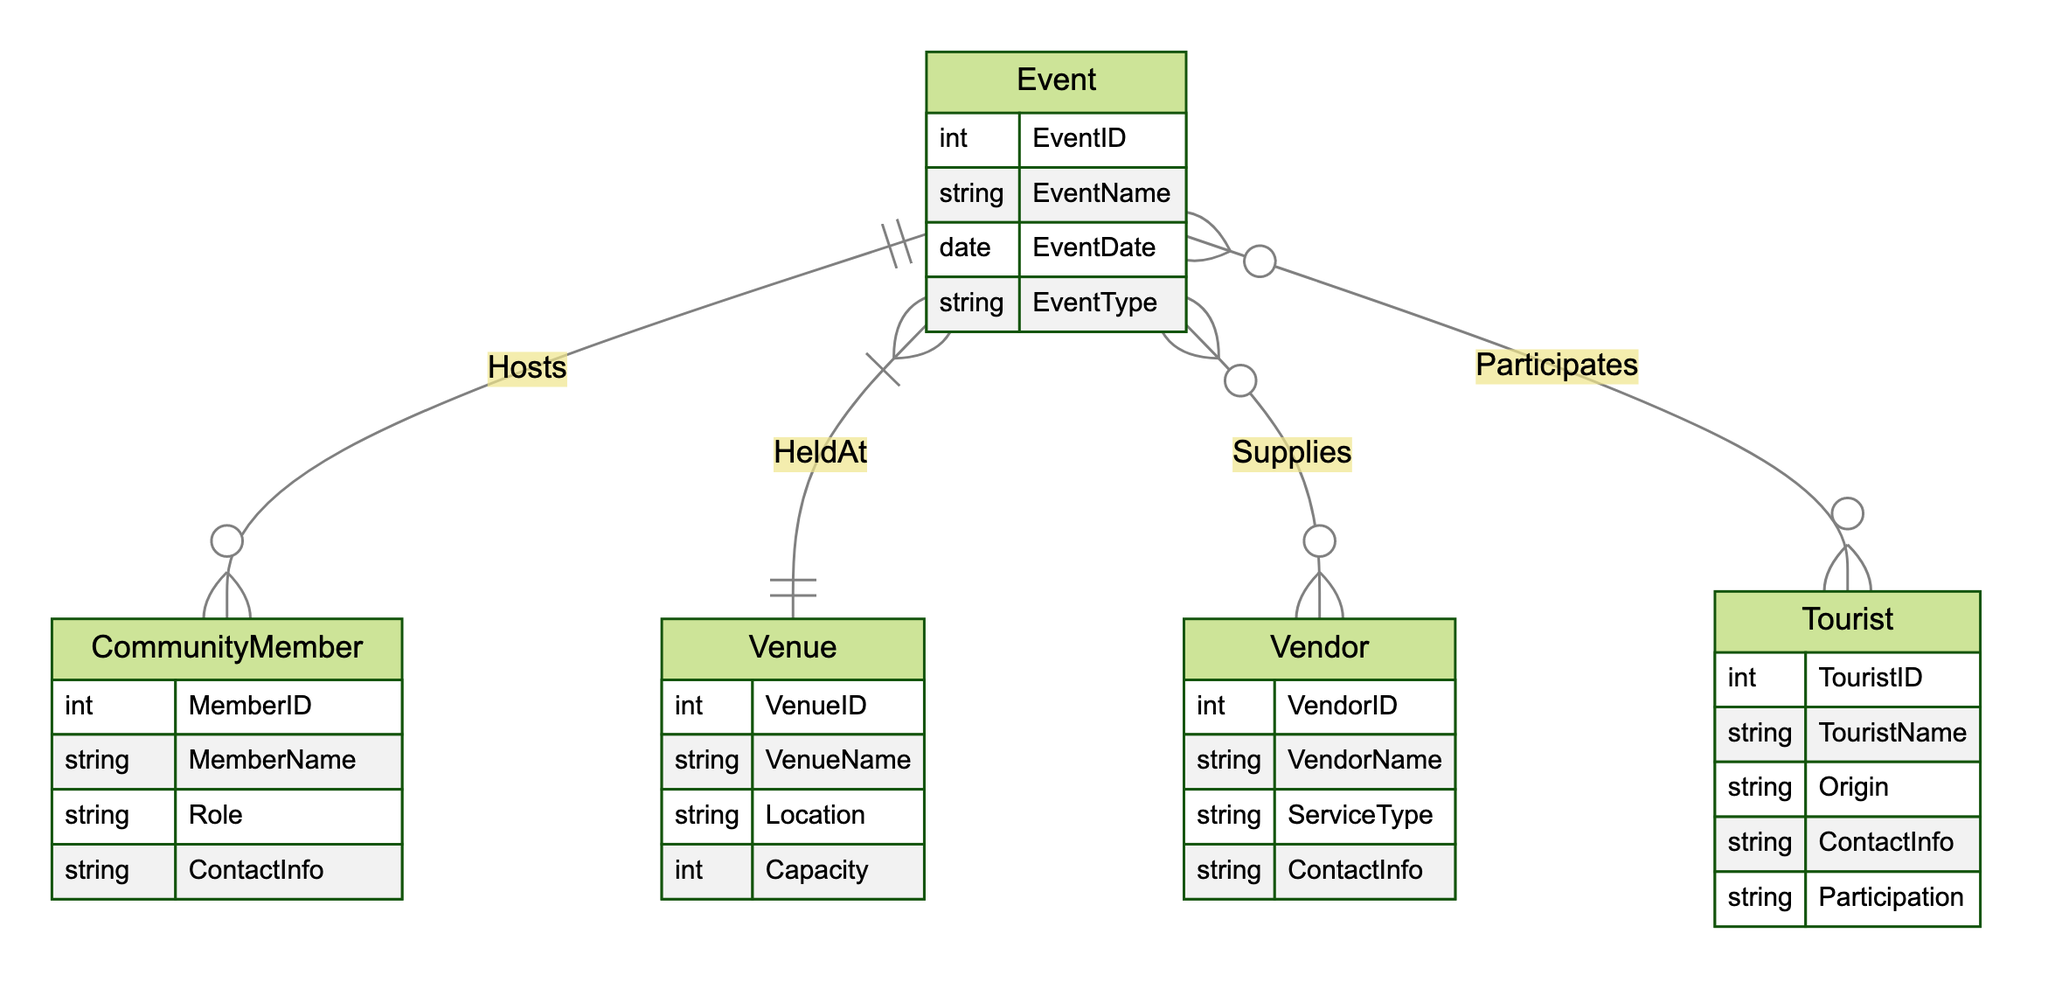What does the "Hosts" relationship represent? The "Hosts" relationship connects the CommunityMember entity with the Event entity, indicating that a community member can host multiple events.
Answer: CommunityMember How many attributes does the Venue entity have? The Venue entity has four attributes: VenueID, VenueName, Location, and Capacity.
Answer: Four What is the relationship type between Event and Venue? The relationship type between Event and Venue is many-to-one. Each event is held at one venue, but a venue can host multiple events.
Answer: Many-to-one Which entity is required for vendors to supply services for events? Vendors are connected to events through the "Supplies" relationship, meaning they provide services for events.
Answer: Vendor How many entities are there in the diagram? The diagram consists of five entities: Event, Venue, Vendor, CommunityMember, and Tourist.
Answer: Five What type of entity is involved in both the "Participates" and "Supplies" relationships? The entity involved in both the "Participates" and "Supplies" relationships is Event, as it connects with both Vendors and Tourists through these relationships.
Answer: Event Which entity has the most relationships connected to it? The Event entity has relationships with CommunityMember (Hosts), Venue (HeldAt), Vendor (Supplies), and Tourist (Participates), indicating it's central in the diagram.
Answer: Event What is the attribute name related to the type of event? The attribute related to the type of event in the Event entity is EventType.
Answer: EventType What is the maximum number of events a community member can host? A community member can host multiple events, as indicated by the one-to-many relationship in the "Hosts" link. There is no specified maximum.
Answer: Multiple 